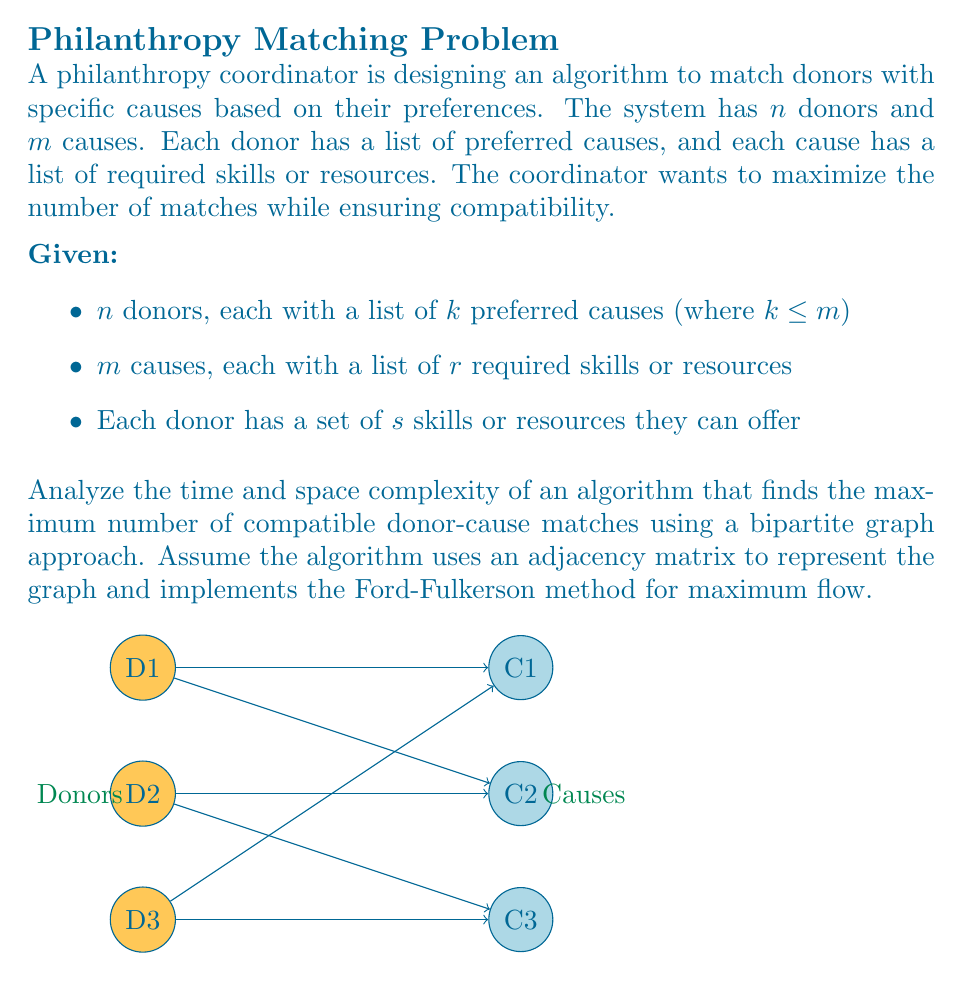Provide a solution to this math problem. Let's analyze the time and space complexity of this algorithm step by step:

1. Building the bipartite graph:
   - Time complexity: $O(nkr)$
     We need to check each donor's $k$ preferred causes against each cause's $r$ required skills.
   - Space complexity: $O(nm)$
     The adjacency matrix requires $n \times m$ space.

2. Ford-Fulkerson method:
   - Time complexity: $O(E \cdot f)$, where $E$ is the number of edges and $f$ is the maximum flow.
     - In our case, $E = O(nm)$ (worst case, all donors connected to all causes)
     - $f \leq \min(n, m)$ (maximum number of matches)
   - Thus, the time complexity becomes $O(nm \cdot \min(n, m))$

3. Finding augmenting paths:
   - Time complexity: $O(E) = O(nm)$ per iteration
   - Space complexity: $O(n + m)$ for the visited array in DFS/BFS

4. Updating residual graph:
   - Time complexity: $O(n + m)$ per augmenting path
   - Space complexity: $O(nm)$ for the residual graph

Overall complexity:
- Time complexity: $O(nm \cdot \min(n, m))$
  This is because steps 3 and 4 are repeated $O(\min(n, m))$ times in the worst case.
- Space complexity: $O(nm)$
  Dominated by the adjacency matrix and residual graph.

Note: The initial graph construction ($O(nkr)$) is typically less significant than the Ford-Fulkerson execution for large $n$ and $m$, unless $k$ and $r$ are exceptionally large.
Answer: Time: $O(nm \cdot \min(n, m))$, Space: $O(nm)$ 